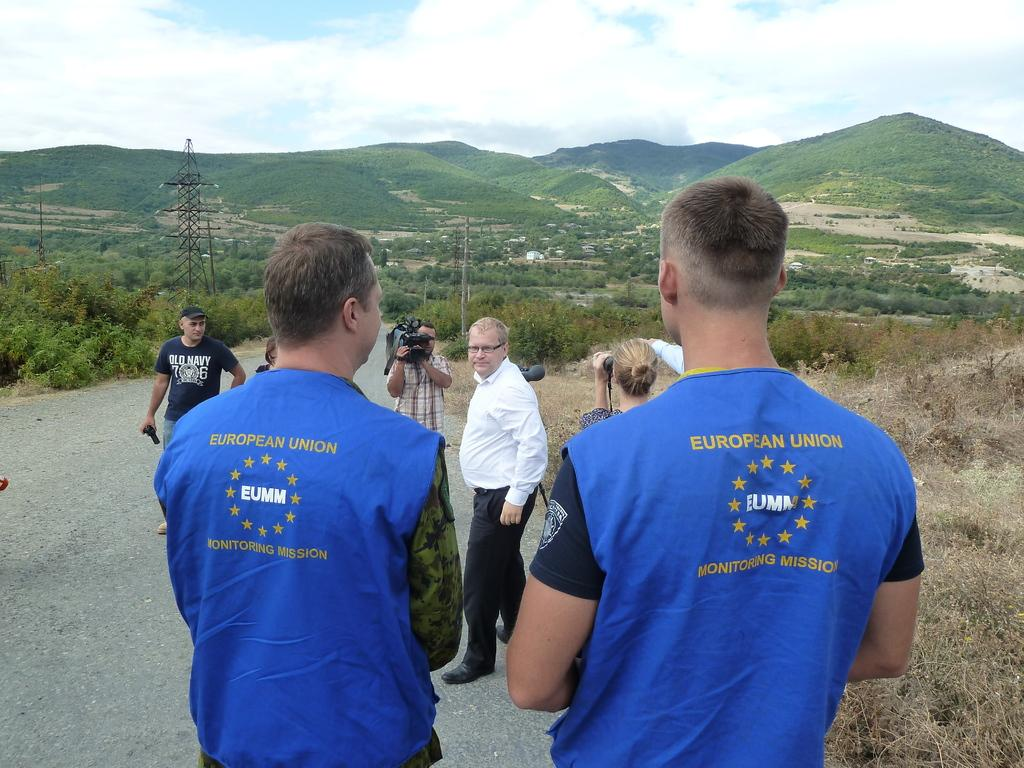What is happening in the center of the image? There are many persons standing on the road in the center of the image. What can be seen in the background of the image? There is a tower, a pole, hills, trees, plants, and the sky visible in the background of the image. Are there any clouds in the sky? Yes, there are clouds in the sky. What type of cream is being used by the expert in the image? There is no expert or cream present in the image. What is the root of the problem being discussed by the persons in the image? There is no discussion or problem being depicted in the image; it simply shows a group of people standing on the road. 